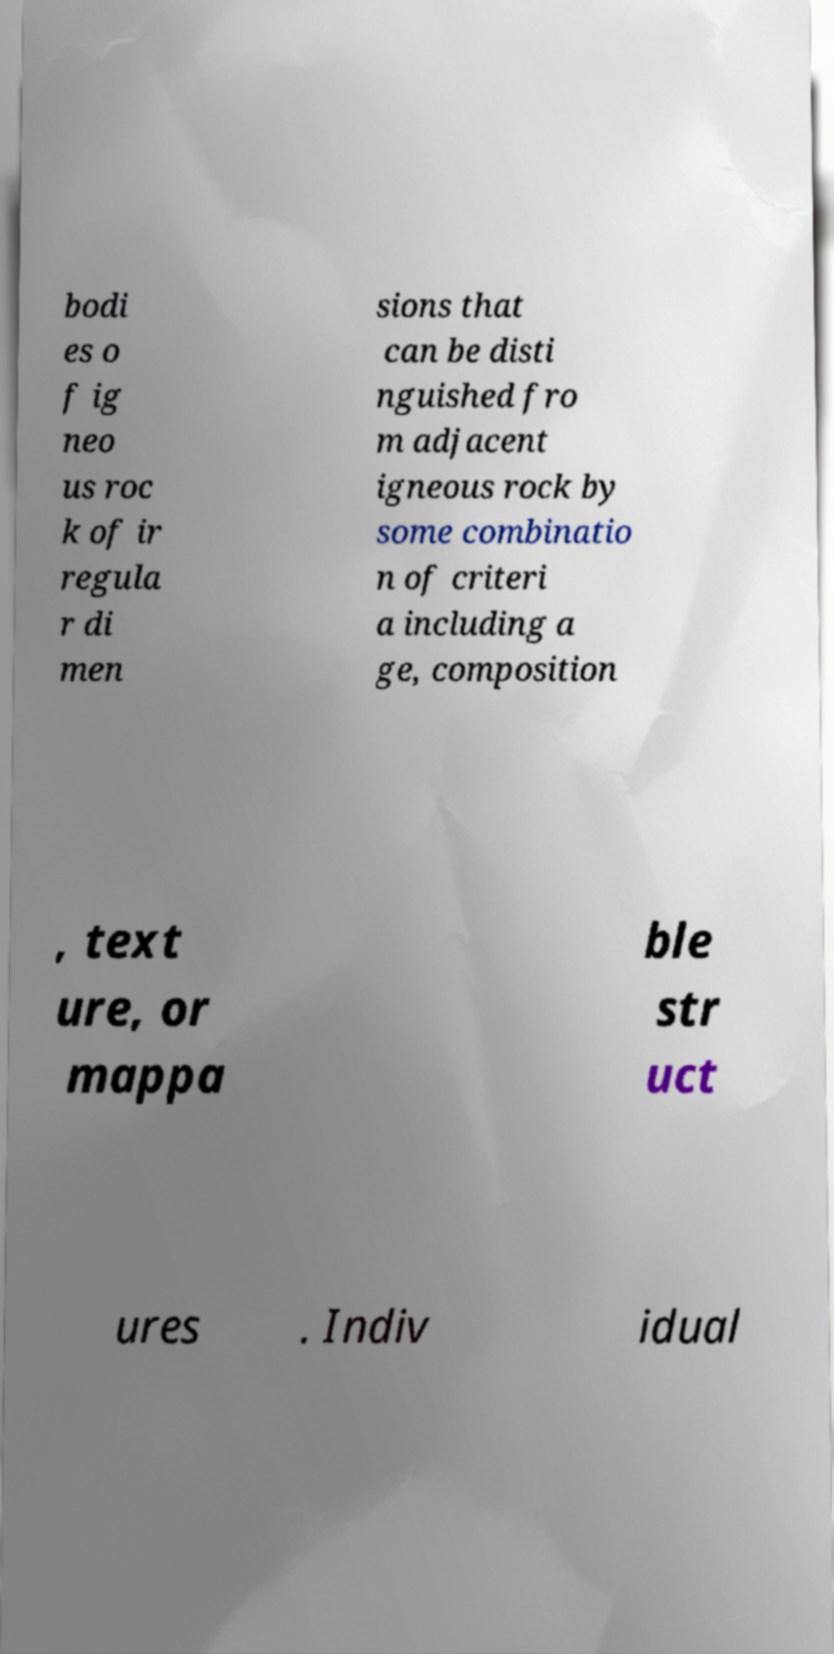For documentation purposes, I need the text within this image transcribed. Could you provide that? bodi es o f ig neo us roc k of ir regula r di men sions that can be disti nguished fro m adjacent igneous rock by some combinatio n of criteri a including a ge, composition , text ure, or mappa ble str uct ures . Indiv idual 